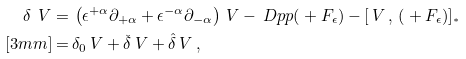<formula> <loc_0><loc_0><loc_500><loc_500>\delta \ V = \, & \left ( \epsilon ^ { + \alpha } \partial _ { + \alpha } + \epsilon ^ { - \alpha } \partial _ { - \alpha } \right ) \ V - \ D p p ( \L + F _ { \epsilon } ) - \left [ \ V \, , \, ( \L + F _ { \epsilon } ) \right ] _ { ^ { * } } \\ [ 3 m m ] = \, & \delta _ { 0 } \ V + \check { \delta } \ V + \hat { \delta } \ V \, ,</formula> 